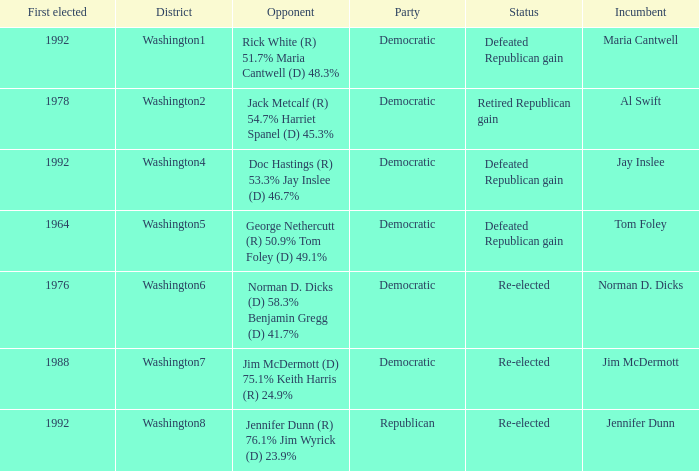What was the result of the election of doc hastings (r) 53.3% jay inslee (d) 46.7% Defeated Republican gain. 